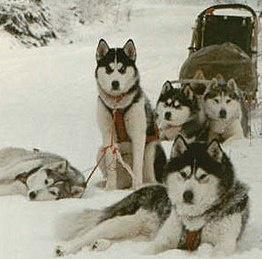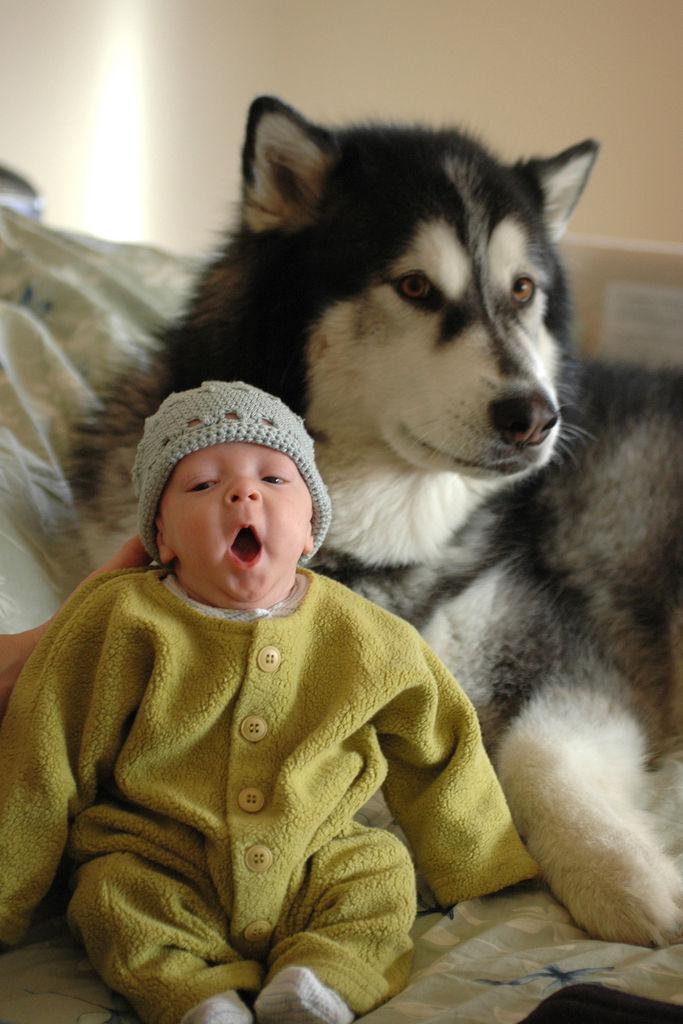The first image is the image on the left, the second image is the image on the right. Considering the images on both sides, is "The dogs in the image on the left are out in the snow." valid? Answer yes or no. Yes. 